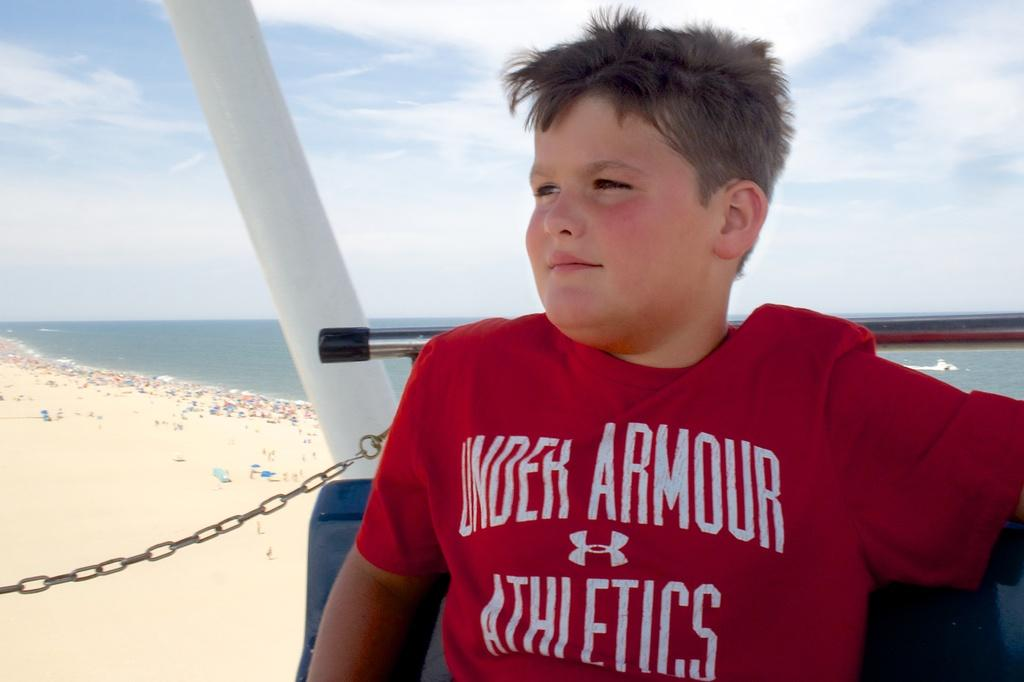What is the person in the image doing? The person is sitting on a chair in the image. What can be seen on the ground in the image? There are objects on the ground in the image. What natural element is visible in the image? Water is visible in the image. What is visible in the background of the image? The sky is visible in the image. Where is the office located in the image? There is no office present in the image. What type of flame can be seen in the image? There is no flame present in the image. 